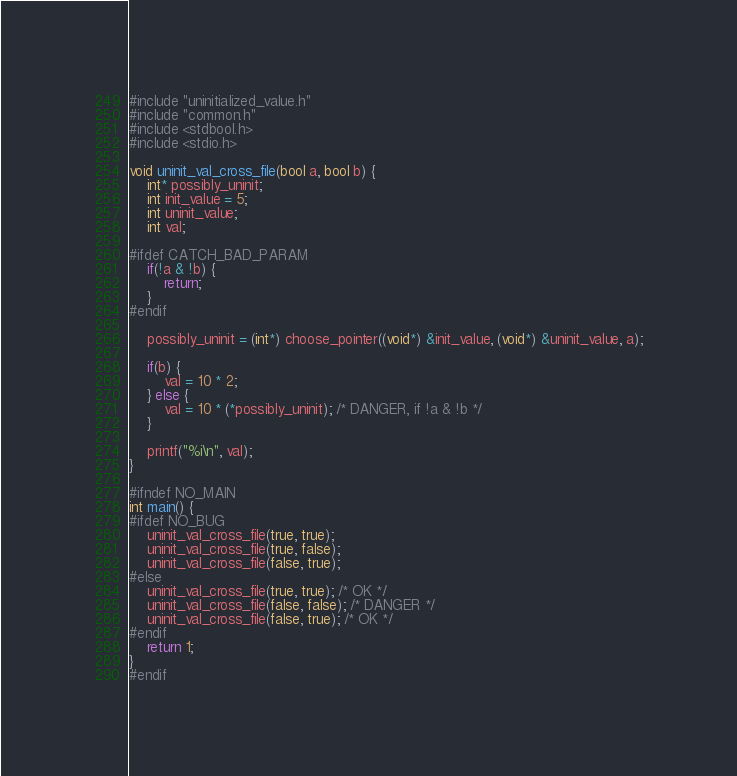<code> <loc_0><loc_0><loc_500><loc_500><_C_>#include "uninitialized_value.h"
#include "common.h"
#include <stdbool.h>
#include <stdio.h>

void uninit_val_cross_file(bool a, bool b) {
    int* possibly_uninit;
    int init_value = 5;
    int uninit_value;
    int val;

#ifdef CATCH_BAD_PARAM
    if(!a & !b) {
        return;
    }
#endif

    possibly_uninit = (int*) choose_pointer((void*) &init_value, (void*) &uninit_value, a);

    if(b) {
        val = 10 * 2;
    } else {
        val = 10 * (*possibly_uninit); /* DANGER, if !a & !b */
    }

    printf("%i\n", val);
}

#ifndef NO_MAIN
int main() {
#ifdef NO_BUG
    uninit_val_cross_file(true, true);
    uninit_val_cross_file(true, false);
    uninit_val_cross_file(false, true);
#else
    uninit_val_cross_file(true, true); /* OK */
    uninit_val_cross_file(false, false); /* DANGER */
    uninit_val_cross_file(false, true); /* OK */
#endif
    return 1;
}
#endif
</code> 